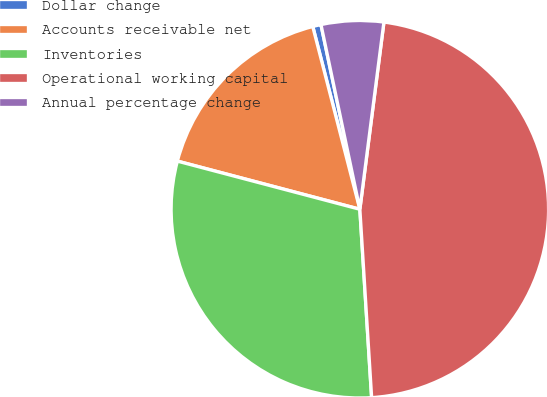<chart> <loc_0><loc_0><loc_500><loc_500><pie_chart><fcel>Dollar change<fcel>Accounts receivable net<fcel>Inventories<fcel>Operational working capital<fcel>Annual percentage change<nl><fcel>0.71%<fcel>16.88%<fcel>30.1%<fcel>46.97%<fcel>5.34%<nl></chart> 